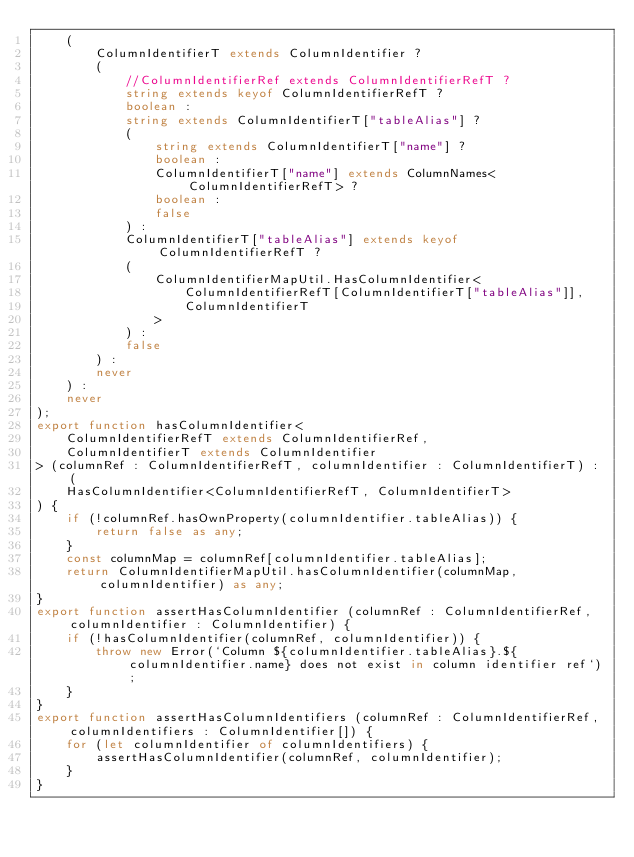Convert code to text. <code><loc_0><loc_0><loc_500><loc_500><_TypeScript_>    (
        ColumnIdentifierT extends ColumnIdentifier ?
        (
            //ColumnIdentifierRef extends ColumnIdentifierRefT ?
            string extends keyof ColumnIdentifierRefT ?
            boolean :
            string extends ColumnIdentifierT["tableAlias"] ?
            (
                string extends ColumnIdentifierT["name"] ?
                boolean :
                ColumnIdentifierT["name"] extends ColumnNames<ColumnIdentifierRefT> ?
                boolean :
                false
            ) :
            ColumnIdentifierT["tableAlias"] extends keyof ColumnIdentifierRefT ?
            (
                ColumnIdentifierMapUtil.HasColumnIdentifier<
                    ColumnIdentifierRefT[ColumnIdentifierT["tableAlias"]],
                    ColumnIdentifierT
                >
            ) :
            false
        ) :
        never
    ) :
    never
);
export function hasColumnIdentifier<
    ColumnIdentifierRefT extends ColumnIdentifierRef,
    ColumnIdentifierT extends ColumnIdentifier
> (columnRef : ColumnIdentifierRefT, columnIdentifier : ColumnIdentifierT) : (
    HasColumnIdentifier<ColumnIdentifierRefT, ColumnIdentifierT>
) {
    if (!columnRef.hasOwnProperty(columnIdentifier.tableAlias)) {
        return false as any;
    }
    const columnMap = columnRef[columnIdentifier.tableAlias];
    return ColumnIdentifierMapUtil.hasColumnIdentifier(columnMap, columnIdentifier) as any;
}
export function assertHasColumnIdentifier (columnRef : ColumnIdentifierRef, columnIdentifier : ColumnIdentifier) {
    if (!hasColumnIdentifier(columnRef, columnIdentifier)) {
        throw new Error(`Column ${columnIdentifier.tableAlias}.${columnIdentifier.name} does not exist in column identifier ref`);
    }
}
export function assertHasColumnIdentifiers (columnRef : ColumnIdentifierRef, columnIdentifiers : ColumnIdentifier[]) {
    for (let columnIdentifier of columnIdentifiers) {
        assertHasColumnIdentifier(columnRef, columnIdentifier);
    }
}</code> 